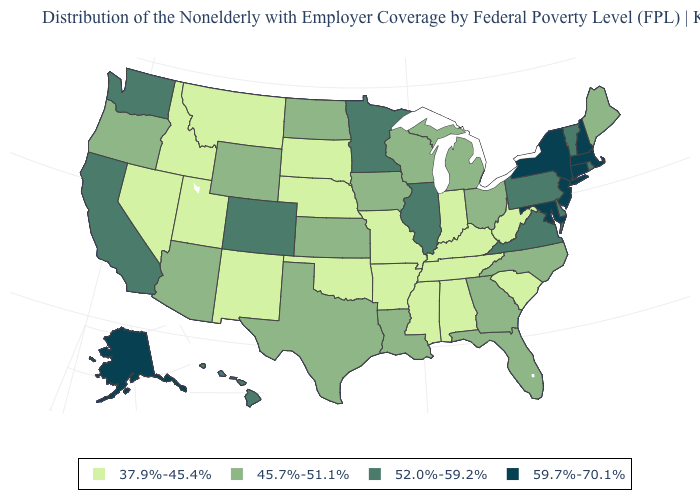Which states have the lowest value in the MidWest?
Keep it brief. Indiana, Missouri, Nebraska, South Dakota. How many symbols are there in the legend?
Short answer required. 4. Name the states that have a value in the range 45.7%-51.1%?
Write a very short answer. Arizona, Florida, Georgia, Iowa, Kansas, Louisiana, Maine, Michigan, North Carolina, North Dakota, Ohio, Oregon, Texas, Wisconsin, Wyoming. Name the states that have a value in the range 59.7%-70.1%?
Write a very short answer. Alaska, Connecticut, Maryland, Massachusetts, New Hampshire, New Jersey, New York. What is the highest value in states that border North Carolina?
Be succinct. 52.0%-59.2%. Name the states that have a value in the range 52.0%-59.2%?
Be succinct. California, Colorado, Delaware, Hawaii, Illinois, Minnesota, Pennsylvania, Rhode Island, Vermont, Virginia, Washington. Name the states that have a value in the range 59.7%-70.1%?
Keep it brief. Alaska, Connecticut, Maryland, Massachusetts, New Hampshire, New Jersey, New York. Name the states that have a value in the range 45.7%-51.1%?
Short answer required. Arizona, Florida, Georgia, Iowa, Kansas, Louisiana, Maine, Michigan, North Carolina, North Dakota, Ohio, Oregon, Texas, Wisconsin, Wyoming. What is the value of Florida?
Keep it brief. 45.7%-51.1%. Which states have the lowest value in the USA?
Answer briefly. Alabama, Arkansas, Idaho, Indiana, Kentucky, Mississippi, Missouri, Montana, Nebraska, Nevada, New Mexico, Oklahoma, South Carolina, South Dakota, Tennessee, Utah, West Virginia. What is the lowest value in the South?
Short answer required. 37.9%-45.4%. Which states have the lowest value in the West?
Be succinct. Idaho, Montana, Nevada, New Mexico, Utah. What is the highest value in states that border South Carolina?
Give a very brief answer. 45.7%-51.1%. Does Maryland have the highest value in the South?
Write a very short answer. Yes. Does Kansas have the lowest value in the MidWest?
Be succinct. No. 